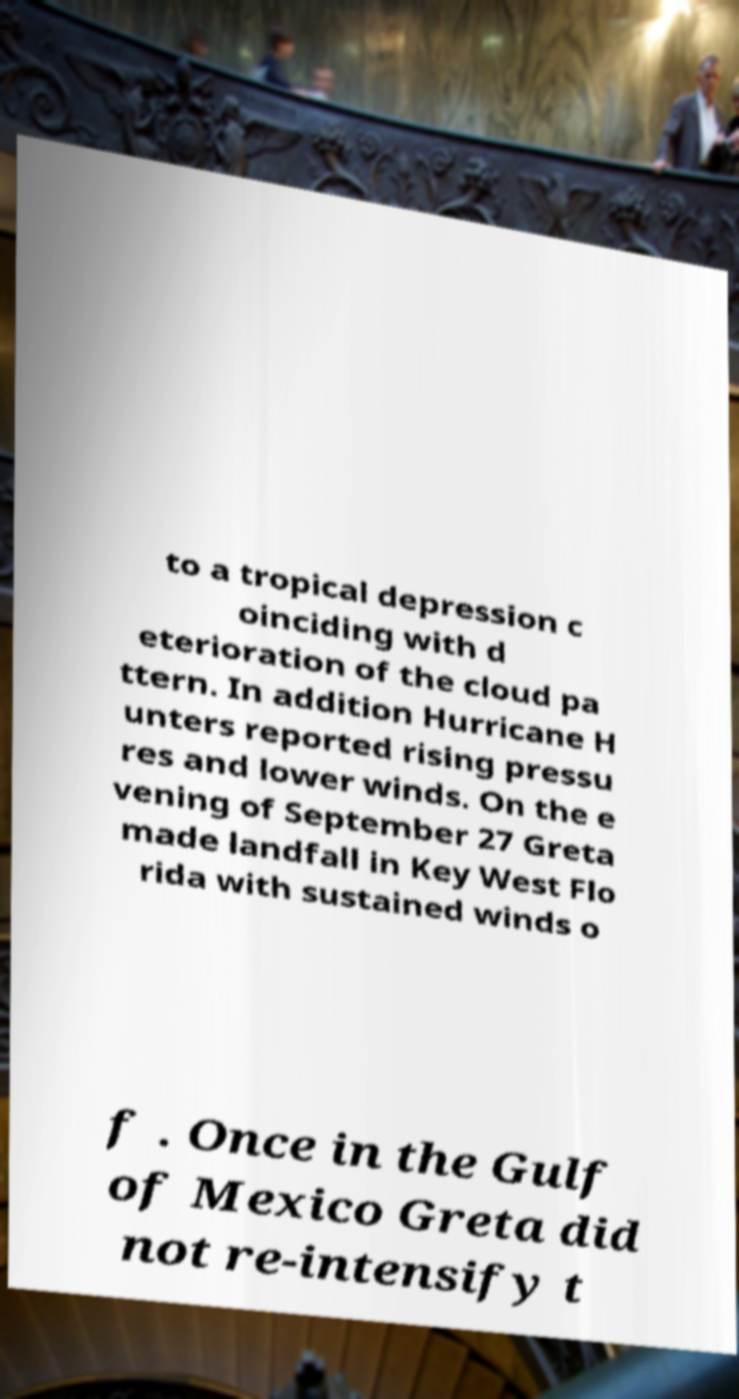I need the written content from this picture converted into text. Can you do that? to a tropical depression c oinciding with d eterioration of the cloud pa ttern. In addition Hurricane H unters reported rising pressu res and lower winds. On the e vening of September 27 Greta made landfall in Key West Flo rida with sustained winds o f . Once in the Gulf of Mexico Greta did not re-intensify t 